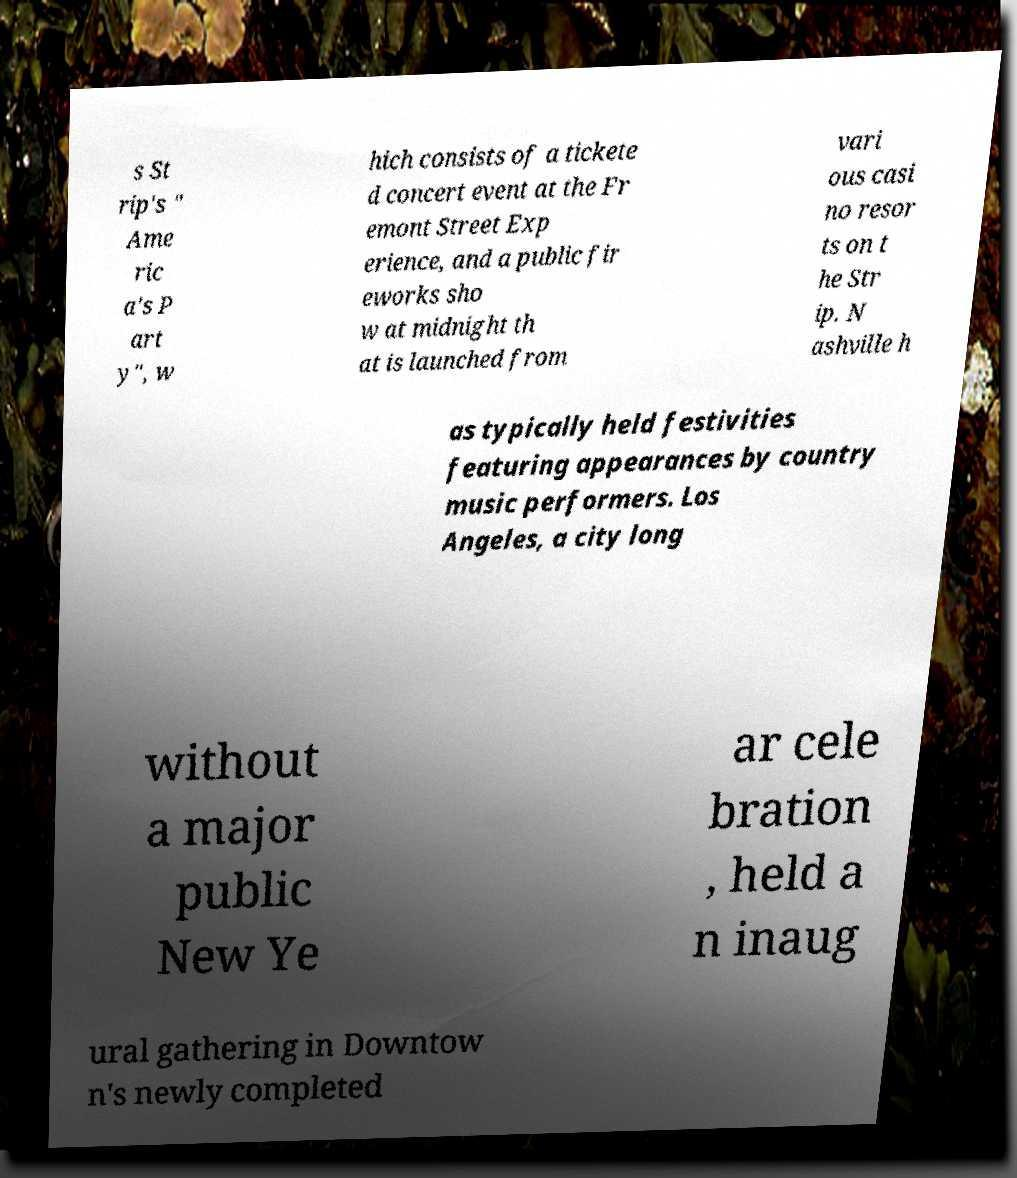Could you assist in decoding the text presented in this image and type it out clearly? s St rip's " Ame ric a's P art y", w hich consists of a tickete d concert event at the Fr emont Street Exp erience, and a public fir eworks sho w at midnight th at is launched from vari ous casi no resor ts on t he Str ip. N ashville h as typically held festivities featuring appearances by country music performers. Los Angeles, a city long without a major public New Ye ar cele bration , held a n inaug ural gathering in Downtow n's newly completed 